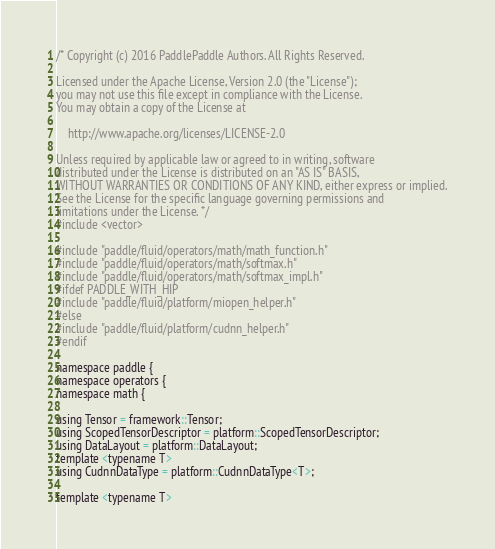Convert code to text. <code><loc_0><loc_0><loc_500><loc_500><_Cuda_>/* Copyright (c) 2016 PaddlePaddle Authors. All Rights Reserved.

Licensed under the Apache License, Version 2.0 (the "License");
you may not use this file except in compliance with the License.
You may obtain a copy of the License at

    http://www.apache.org/licenses/LICENSE-2.0

Unless required by applicable law or agreed to in writing, software
distributed under the License is distributed on an "AS IS" BASIS,
WITHOUT WARRANTIES OR CONDITIONS OF ANY KIND, either express or implied.
See the License for the specific language governing permissions and
limitations under the License. */
#include <vector>

#include "paddle/fluid/operators/math/math_function.h"
#include "paddle/fluid/operators/math/softmax.h"
#include "paddle/fluid/operators/math/softmax_impl.h"
#ifdef PADDLE_WITH_HIP
#include "paddle/fluid/platform/miopen_helper.h"
#else
#include "paddle/fluid/platform/cudnn_helper.h"
#endif

namespace paddle {
namespace operators {
namespace math {

using Tensor = framework::Tensor;
using ScopedTensorDescriptor = platform::ScopedTensorDescriptor;
using DataLayout = platform::DataLayout;
template <typename T>
using CudnnDataType = platform::CudnnDataType<T>;

template <typename T></code> 